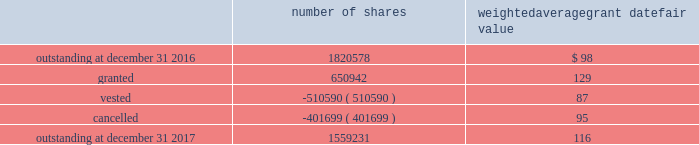In 2017 , the company granted 440076 shares of restricted class a common stock and 7568 shares of restricted stock units .
Restricted common stock and restricted stock units generally have a vesting period of two to four years .
The fair value related to these grants was $ 58.7 million , which is recognized as compensation expense on an accelerated basis over the vesting period .
Dividends are accrued on restricted class a common stock and restricted stock units and are paid once the restricted stock vests .
In 2017 , the company also granted 203298 performance shares .
The fair value related to these grants was $ 25.3 million , which is recognized as compensation expense on an accelerated and straight-lined basis over the vesting period .
The vesting of these shares is contingent on meeting stated performance or market conditions .
The table summarizes restricted stock , restricted stock units , and performance shares activity for 2017 : number of shares weighted average grant date fair value .
The total fair value of restricted stock , restricted stock units , and performance shares that vested during 2017 , 2016 and 2015 was $ 66.0 million , $ 59.8 million and $ 43.3 million , respectively .
Under the espp , eligible employees may acquire shares of class a common stock using after-tax payroll deductions made during consecutive offering periods of approximately six months in duration .
Shares are purchased at the end of each offering period at a price of 90% ( 90 % ) of the closing price of the class a common stock as reported on the nasdaq global select market .
Compensation expense is recognized on the dates of purchase for the discount from the closing price .
In 2017 , 2016 and 2015 , a total of 19936 , 19858 and 19756 shares , respectively , of class a common stock were issued to participating employees .
These shares are subject to a six-month holding period .
Annual expense of $ 0.3 million for the purchase discount was recognized in 2017 , and $ 0.2 million was recognized in both 2016 and 2015 .
Non-executive directors receive an annual award of class a common stock with a value equal to $ 100000 .
Non-executive directors may also elect to receive some or all of the cash portion of their annual stipend , up to $ 60000 , in shares of stock based on the closing price at the date of distribution .
As a result , 19736 shares , 26439 shares and 25853 shares of class a common stock were issued to non-executive directors during 2017 , 2016 and 2015 , respectively .
These shares are not subject to any vesting restrictions .
Expense of $ 2.5 million , $ 2.4 million and $ 2.5 million related to these stock-based payments was recognized for the years ended december 31 , 2017 , 2016 and 2015 , respectively. .
For the 2017 restricted common stock and restricted stock unit grants , assuming the average vesting period , what would annual compensation expense be in millions over the vesting period? 
Computations: (58.7 / ((2 + 4) / 2))
Answer: 19.56667. 